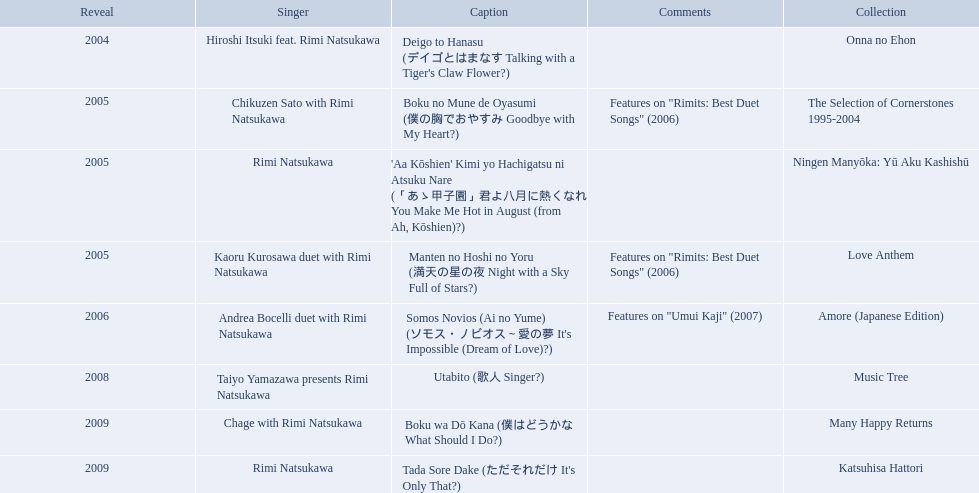In what year was the premiere title introduced? 2004. 